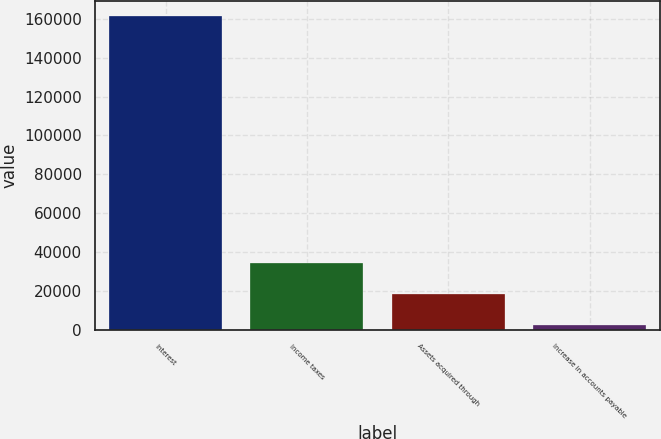Convert chart. <chart><loc_0><loc_0><loc_500><loc_500><bar_chart><fcel>Interest<fcel>Income taxes<fcel>Assets acquired through<fcel>Increase in accounts payable<nl><fcel>161257<fcel>34227.4<fcel>18348.7<fcel>2470<nl></chart> 